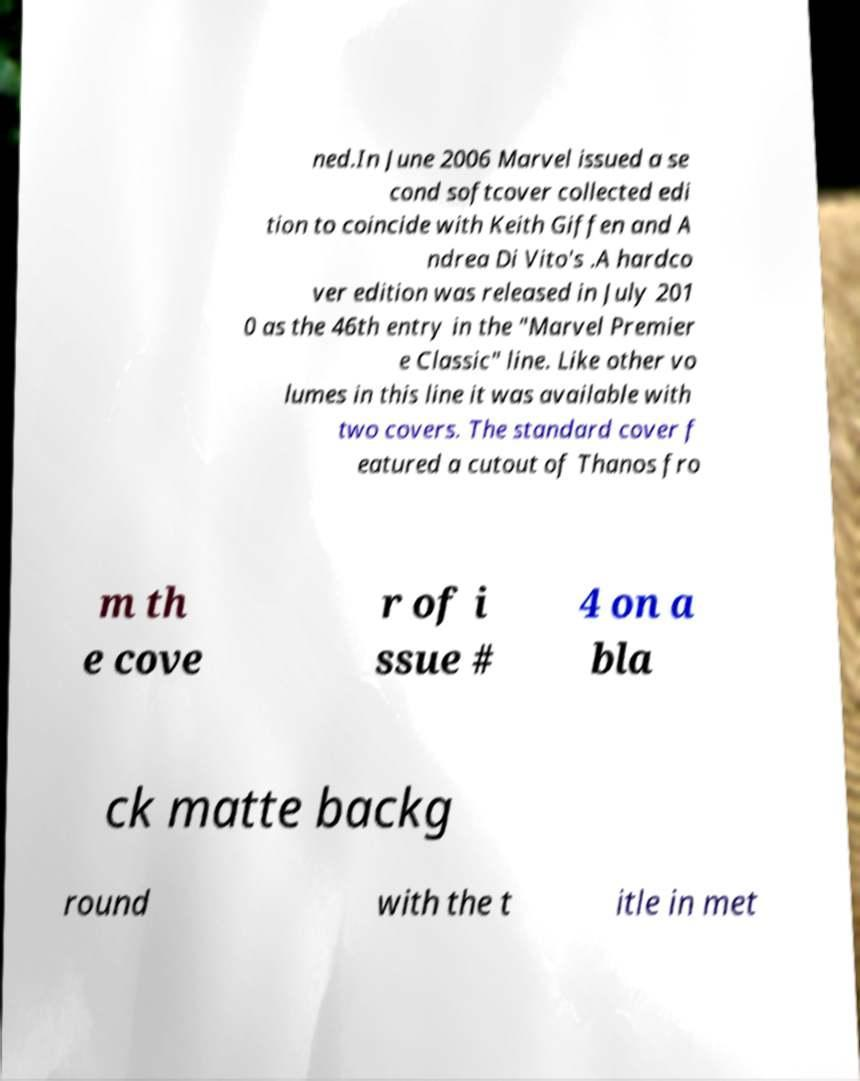For documentation purposes, I need the text within this image transcribed. Could you provide that? ned.In June 2006 Marvel issued a se cond softcover collected edi tion to coincide with Keith Giffen and A ndrea Di Vito's .A hardco ver edition was released in July 201 0 as the 46th entry in the "Marvel Premier e Classic" line. Like other vo lumes in this line it was available with two covers. The standard cover f eatured a cutout of Thanos fro m th e cove r of i ssue # 4 on a bla ck matte backg round with the t itle in met 